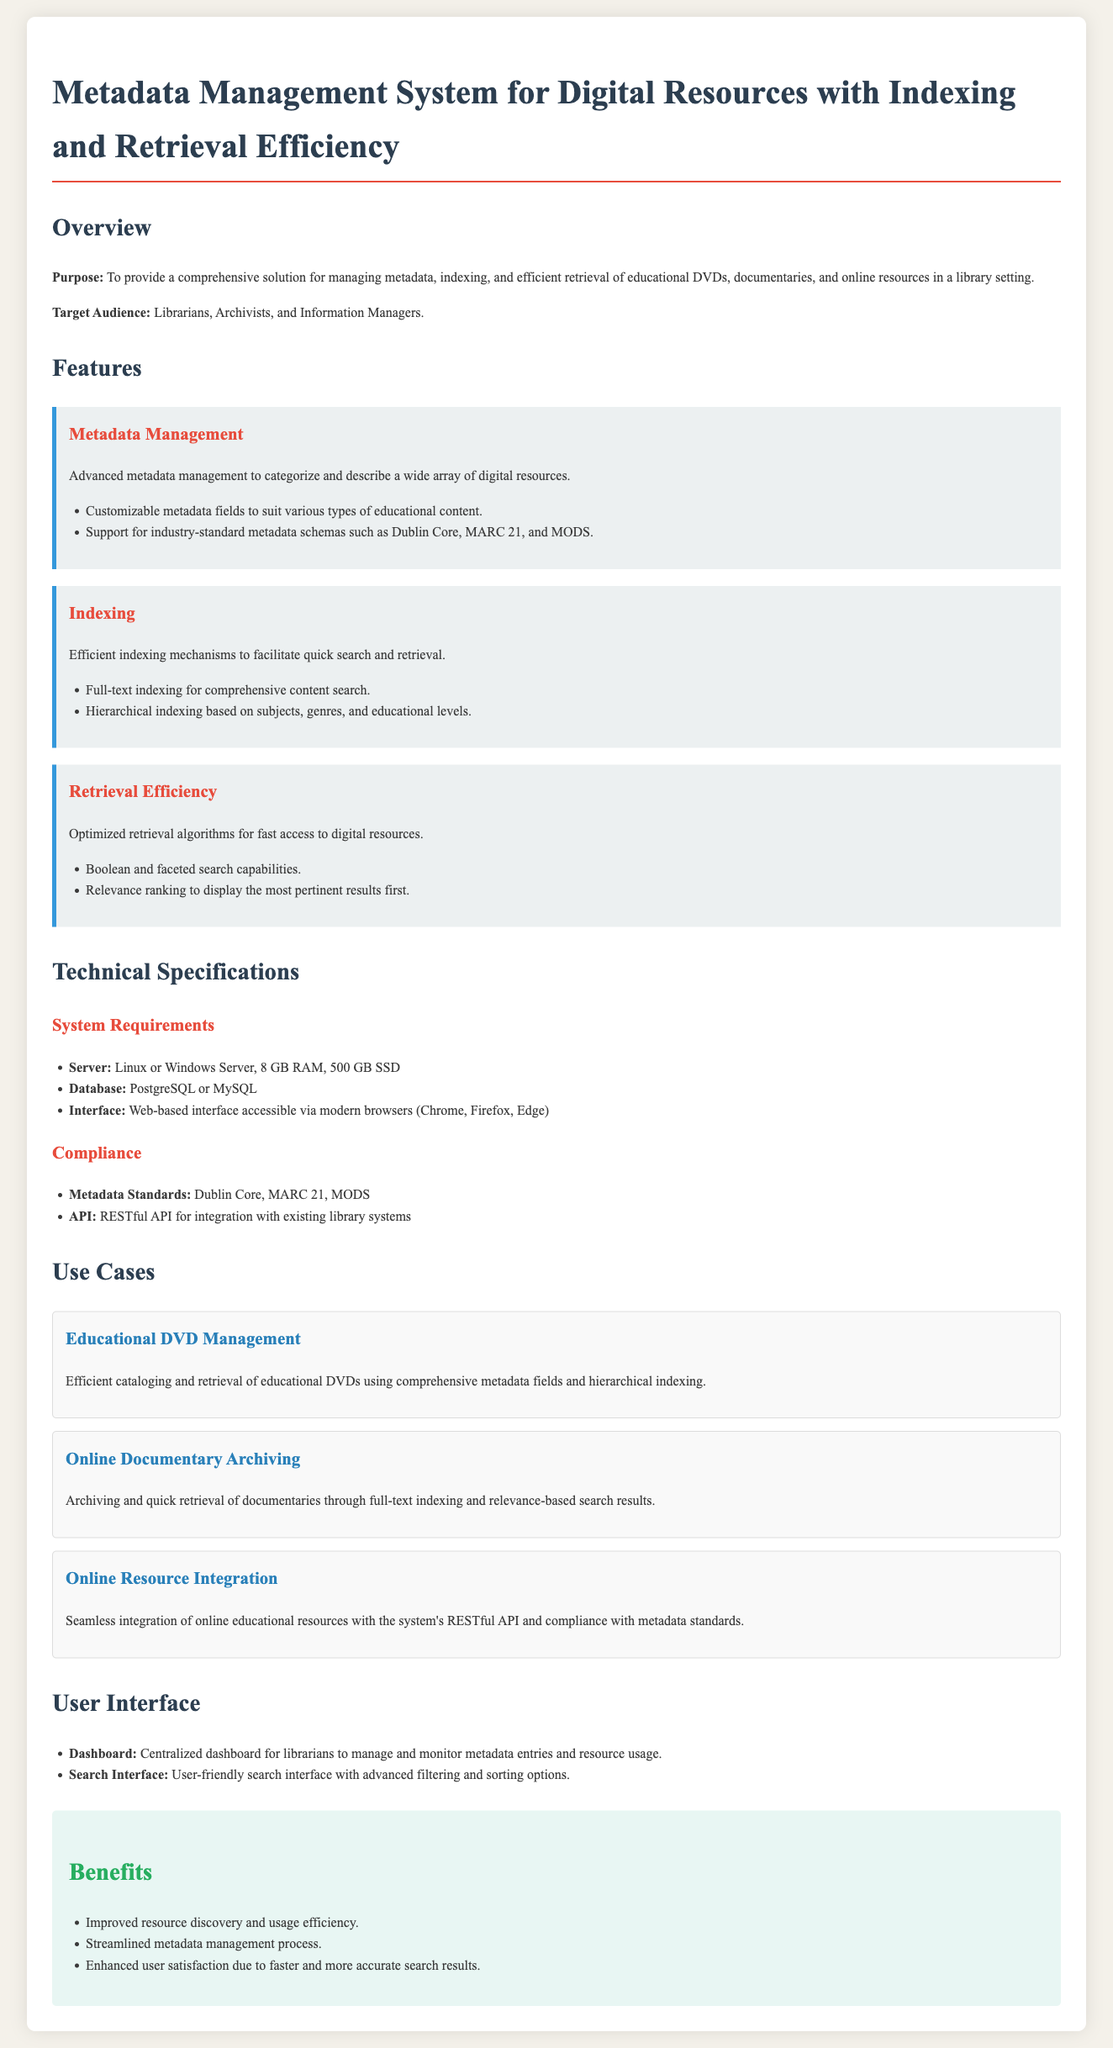What is the purpose of the system? The purpose is to provide a comprehensive solution for managing metadata, indexing, and efficient retrieval of digital resources in a library setting.
Answer: Comprehensive solution for managing metadata Who is the target audience? The target audience includes professionals who will benefit from the system, mentioned in the document.
Answer: Librarians, Archivists, and Information Managers Which metadata standards does the system support? The document lists specific metadata standards that the system is compliant with in the compliance section.
Answer: Dublin Core, MARC 21, MODS What indexing feature does the system offer? The document outlines specific indexing features available in the system.
Answer: Full-text indexing What does the user interface include? The user interface description in the document mentions specific components available to the user.
Answer: Dashboard and Search Interface How much RAM is recommended for the server? The technical specifications section provides system requirements, including RAM needed.
Answer: 8 GB RAM What is a use case for online documentary archiving? The document provides practical scenarios demonstrating how the system can be utilized.
Answer: Archiving and quick retrieval of documentaries What is one benefit of the system? The benefits section highlights several advantages of utilizing this system, and one example can be extracted.
Answer: Improved resource discovery and usage efficiency What type of search capabilities are mentioned? The features section includes specific capabilities of the search functionality within the system.
Answer: Boolean and faceted search capabilities 